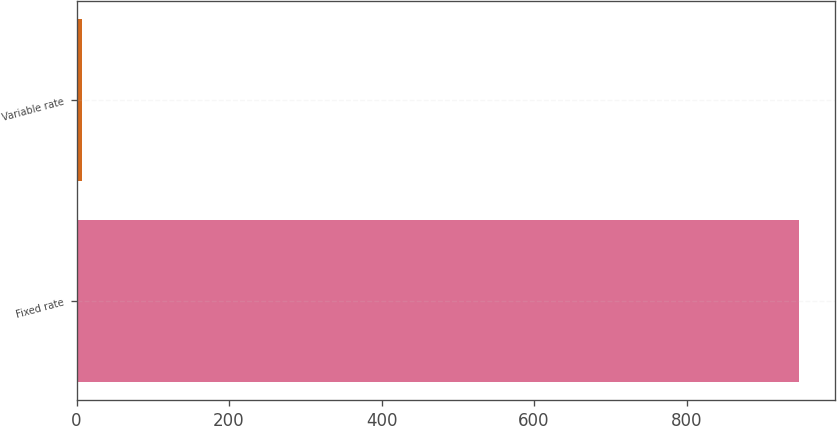Convert chart. <chart><loc_0><loc_0><loc_500><loc_500><bar_chart><fcel>Fixed rate<fcel>Variable rate<nl><fcel>948<fcel>7<nl></chart> 